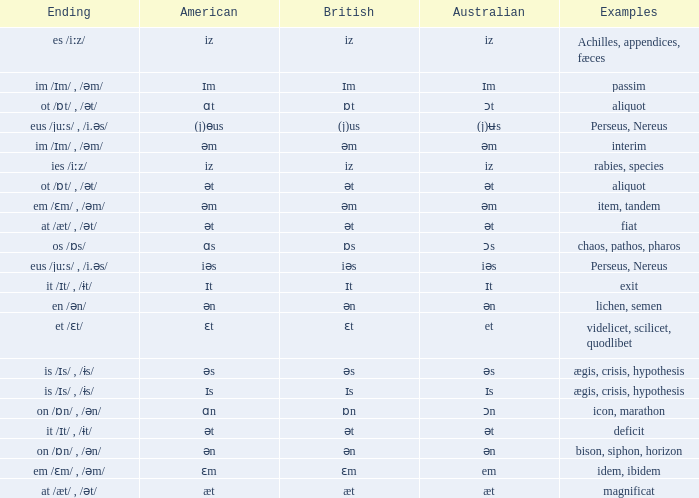Which american possesses british of ɛm? Ɛm. 